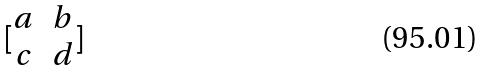<formula> <loc_0><loc_0><loc_500><loc_500>[ \begin{matrix} a & b \\ c & d \\ \end{matrix} ]</formula> 